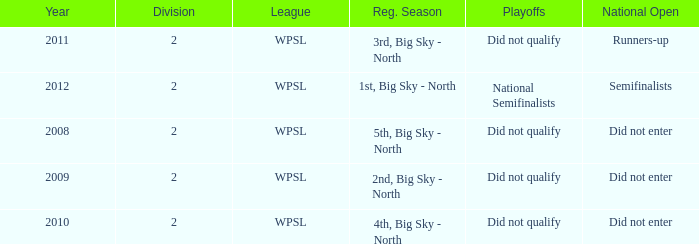What is the lowest division number? 2.0. 